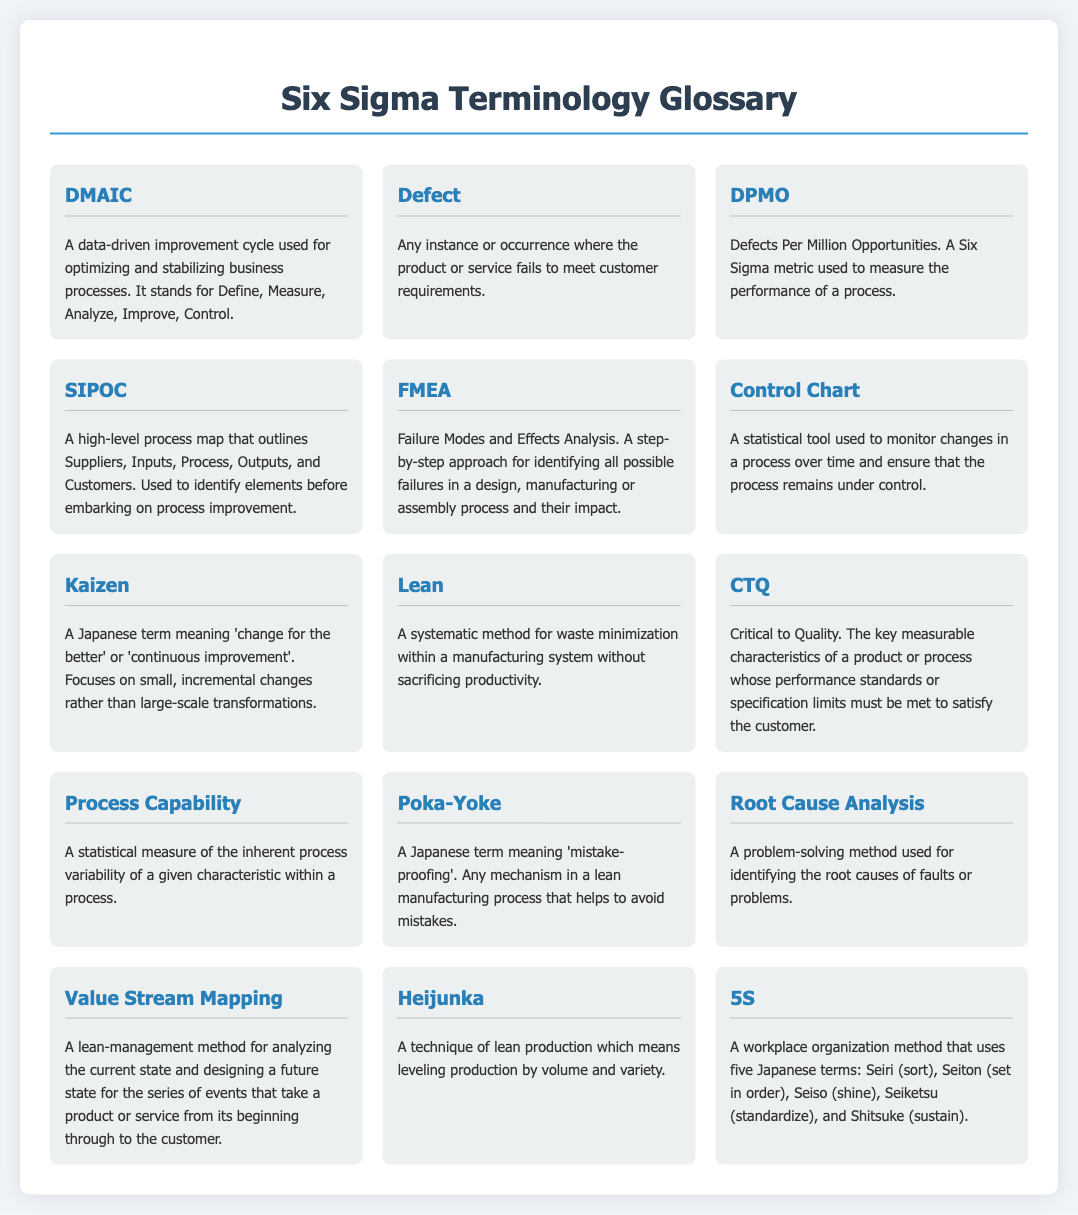What does DMAIC stand for? DMAIC stands for Define, Measure, Analyze, Improve, Control, which are the five phases of the data-driven improvement cycle.
Answer: Define, Measure, Analyze, Improve, Control What is a defect? A defect is defined as any instance or occurrence where the product or service fails to meet customer requirements.
Answer: Any instance or occurrence where the product or service fails to meet customer requirements What does DPMO measure? DPMO measures the performance of a process, specifically in terms of defects per million opportunities.
Answer: Defects Per Million Opportunities What is SIPOC used for? SIPOC is used to identify elements before embarking on process improvement by outlining Suppliers, Inputs, Process, Outputs, and Customers.
Answer: Identify elements before process improvement What is the purpose of a Control Chart? A Control Chart is a statistical tool used to monitor changes in a process over time to ensure control.
Answer: Monitor changes in a process over time What does Kaizen mean? Kaizen is a Japanese term meaning 'change for the better' or 'continuous improvement'.
Answer: Change for the better Which method uses five Japanese terms for workplace organization? The method that uses five Japanese terms for workplace organization is called 5S.
Answer: 5S What does CTQ stand for? CTQ stands for Critical to Quality, which refers to the key measurable characteristics of a product or process.
Answer: Critical to Quality What is FMEA? FMEA stands for Failure Modes and Effects Analysis, a step-by-step approach to identify possible failures and their impacts.
Answer: Failure Modes and Effects Analysis 